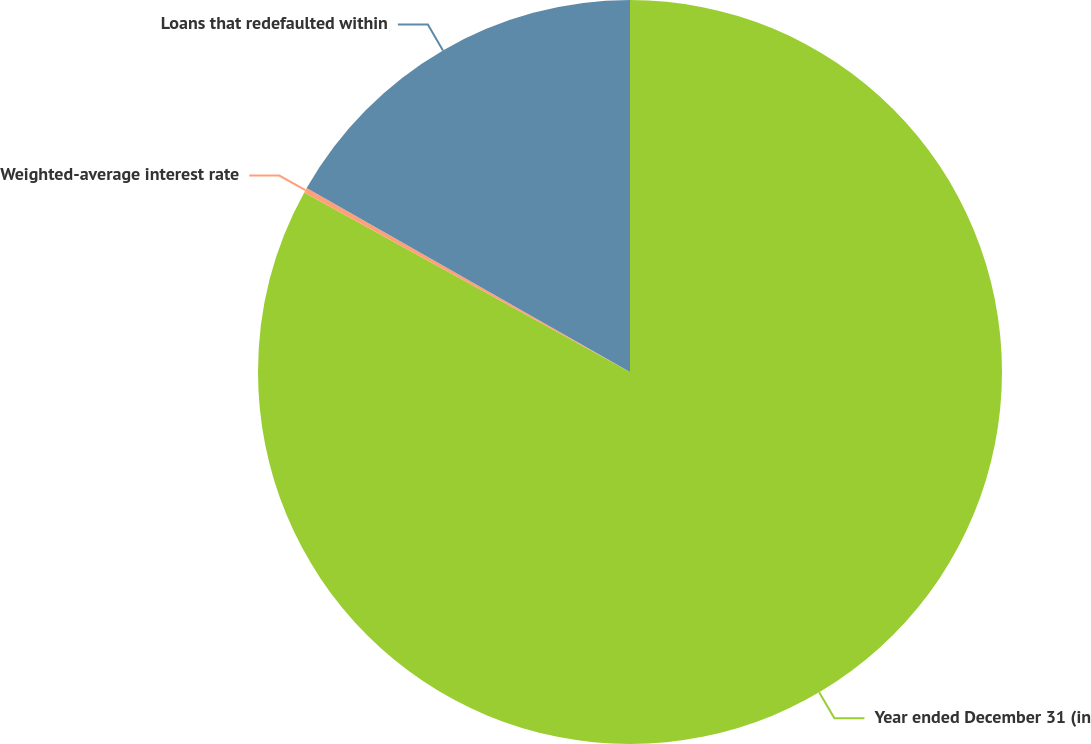Convert chart. <chart><loc_0><loc_0><loc_500><loc_500><pie_chart><fcel>Year ended December 31 (in<fcel>Weighted-average interest rate<fcel>Loans that redefaulted within<nl><fcel>83.02%<fcel>0.21%<fcel>16.77%<nl></chart> 